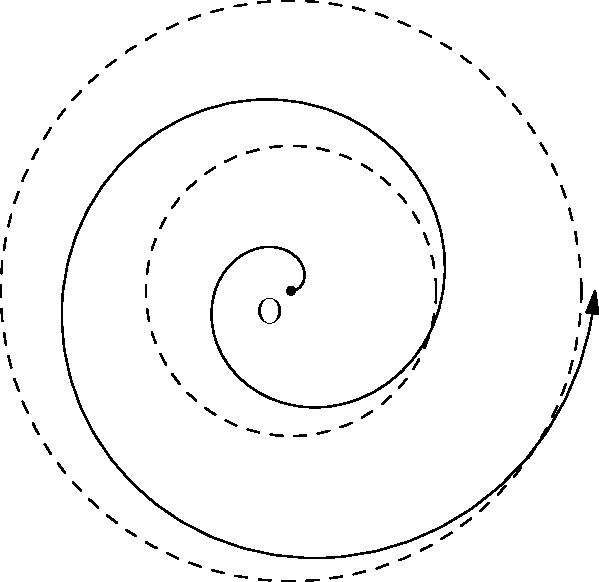A clever raccoon is being pursued by a trapper who sets up a spiral-shaped trap. The trap's boundary is defined by the polar equation $r = 0.2\theta$, where $r$ is in meters and $\theta$ is in radians. If the trap extends for two complete revolutions, what is the area (in square meters) that the raccoon must avoid? Round your answer to two decimal places. To solve this problem, we'll follow these steps:

1) The area of a polar curve is given by the formula:

   $$A = \frac{1}{2} \int_a^b r^2(\theta) d\theta$$

2) In this case, $r(\theta) = 0.2\theta$, $a = 0$, and $b = 4\pi$ (two complete revolutions).

3) Substituting into the formula:

   $$A = \frac{1}{2} \int_0^{4\pi} (0.2\theta)^2 d\theta$$

4) Simplify the integrand:

   $$A = \frac{1}{2} \int_0^{4\pi} 0.04\theta^2 d\theta$$

5) Integrate:

   $$A = \frac{1}{2} \cdot 0.04 \cdot \frac{\theta^3}{3} \bigg|_0^{4\pi}$$

6) Evaluate the integral:

   $$A = 0.02 \cdot \frac{(4\pi)^3}{3} - 0$$

7) Simplify:

   $$A = \frac{128\pi^3}{150} \approx 8.3776$$

8) Rounding to two decimal places:

   $$A \approx 8.38 \text{ square meters}$$
Answer: 8.38 m² 